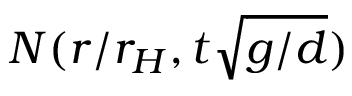Convert formula to latex. <formula><loc_0><loc_0><loc_500><loc_500>N ( r / r _ { H } , t \sqrt { g / d } )</formula> 